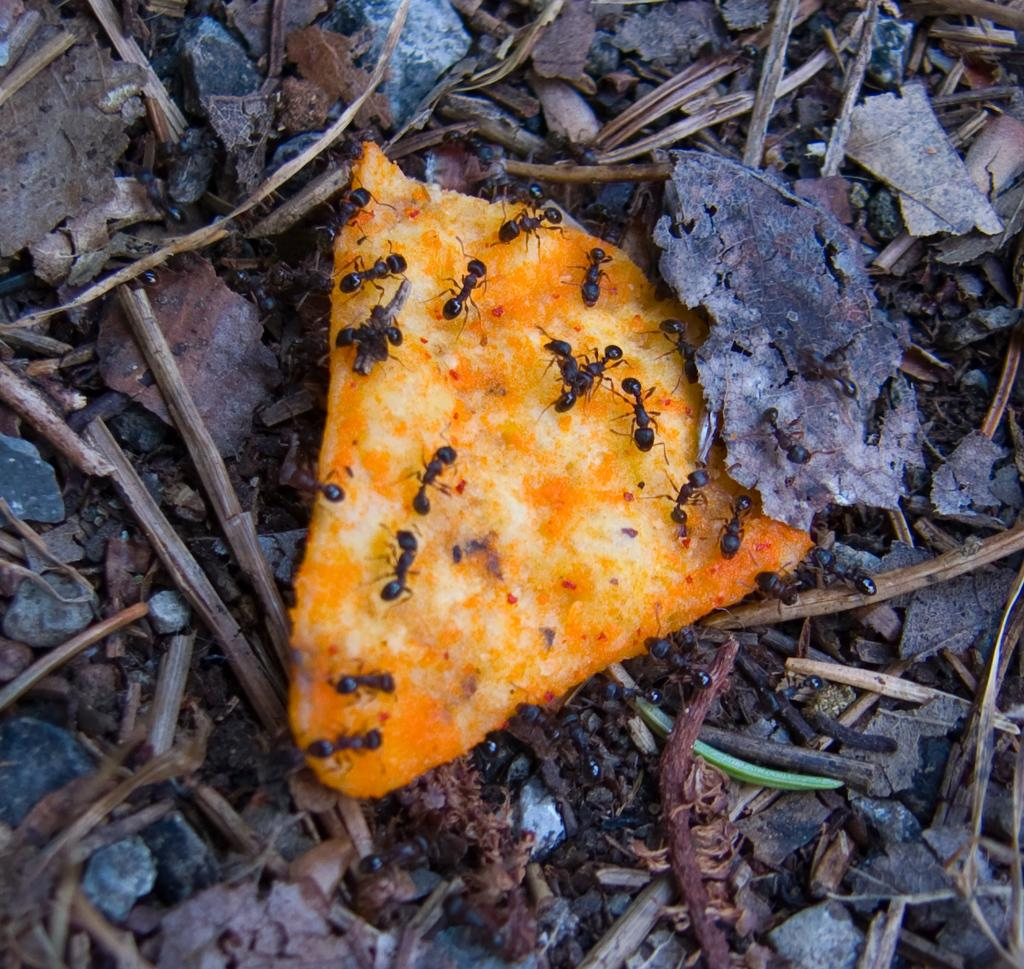What is on the ground in the image? There is a piece of food on the ground in the image. What is crawling on the piece of food? There are black color ants on the food. Can you hear the frog croaking in the image? There is no frog present in the image, so it is not possible to hear any croaking. 